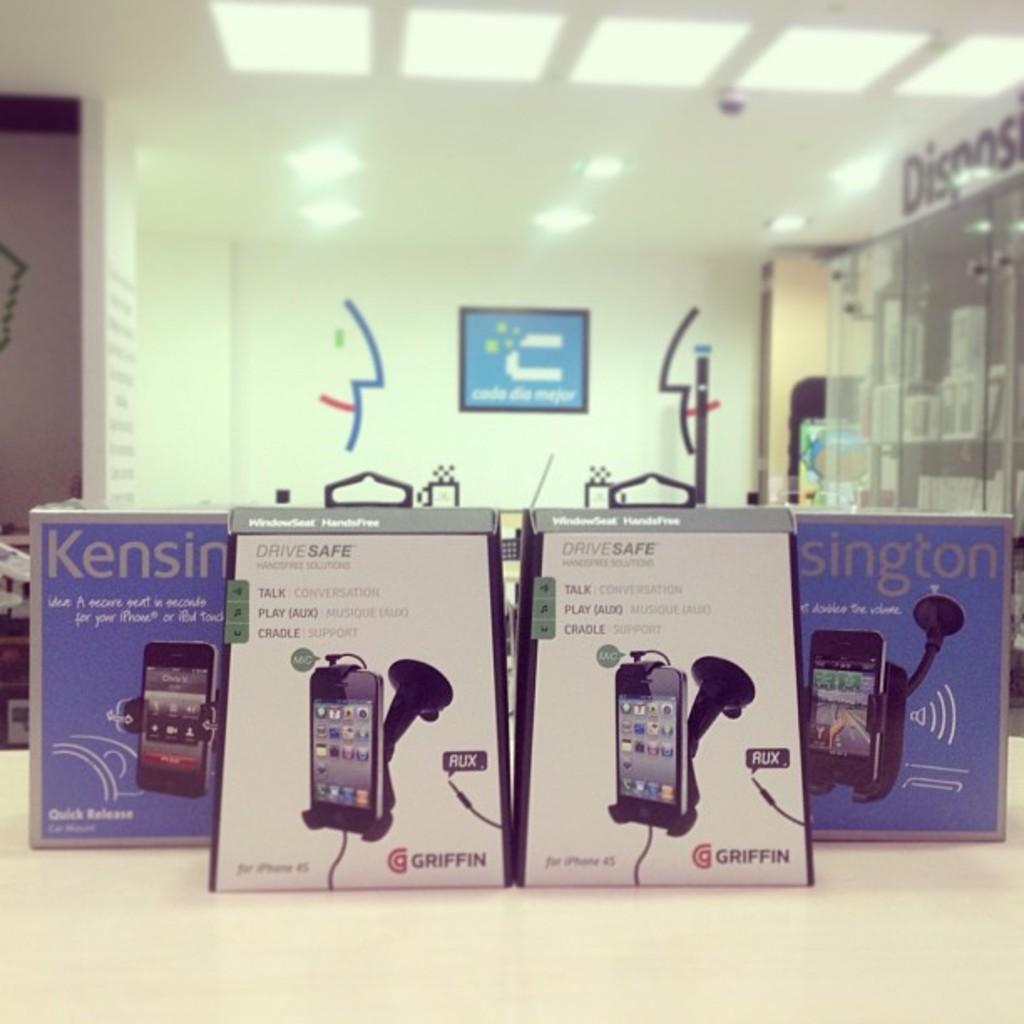What brand is the phone stand in the box?
Give a very brief answer. Kensington. 